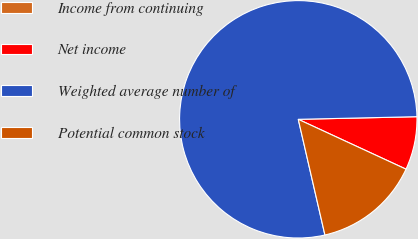<chart> <loc_0><loc_0><loc_500><loc_500><pie_chart><fcel>Income from continuing<fcel>Net income<fcel>Weighted average number of<fcel>Potential common stock<nl><fcel>0.0%<fcel>7.25%<fcel>78.25%<fcel>14.5%<nl></chart> 